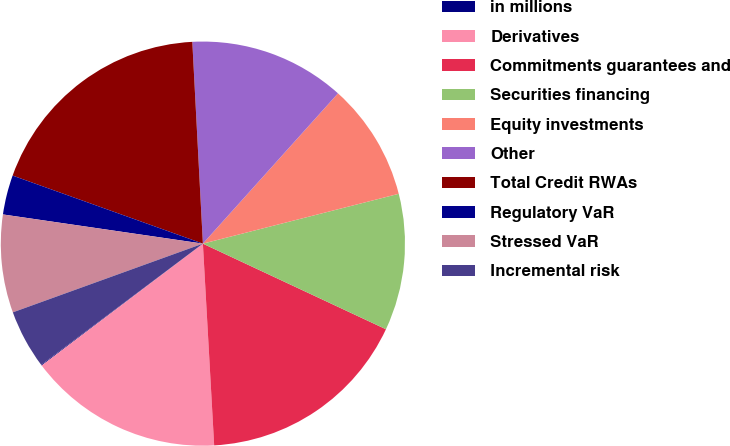<chart> <loc_0><loc_0><loc_500><loc_500><pie_chart><fcel>in millions<fcel>Derivatives<fcel>Commitments guarantees and<fcel>Securities financing<fcel>Equity investments<fcel>Other<fcel>Total Credit RWAs<fcel>Regulatory VaR<fcel>Stressed VaR<fcel>Incremental risk<nl><fcel>0.06%<fcel>15.59%<fcel>17.15%<fcel>10.93%<fcel>9.38%<fcel>12.49%<fcel>18.7%<fcel>3.16%<fcel>7.83%<fcel>4.72%<nl></chart> 